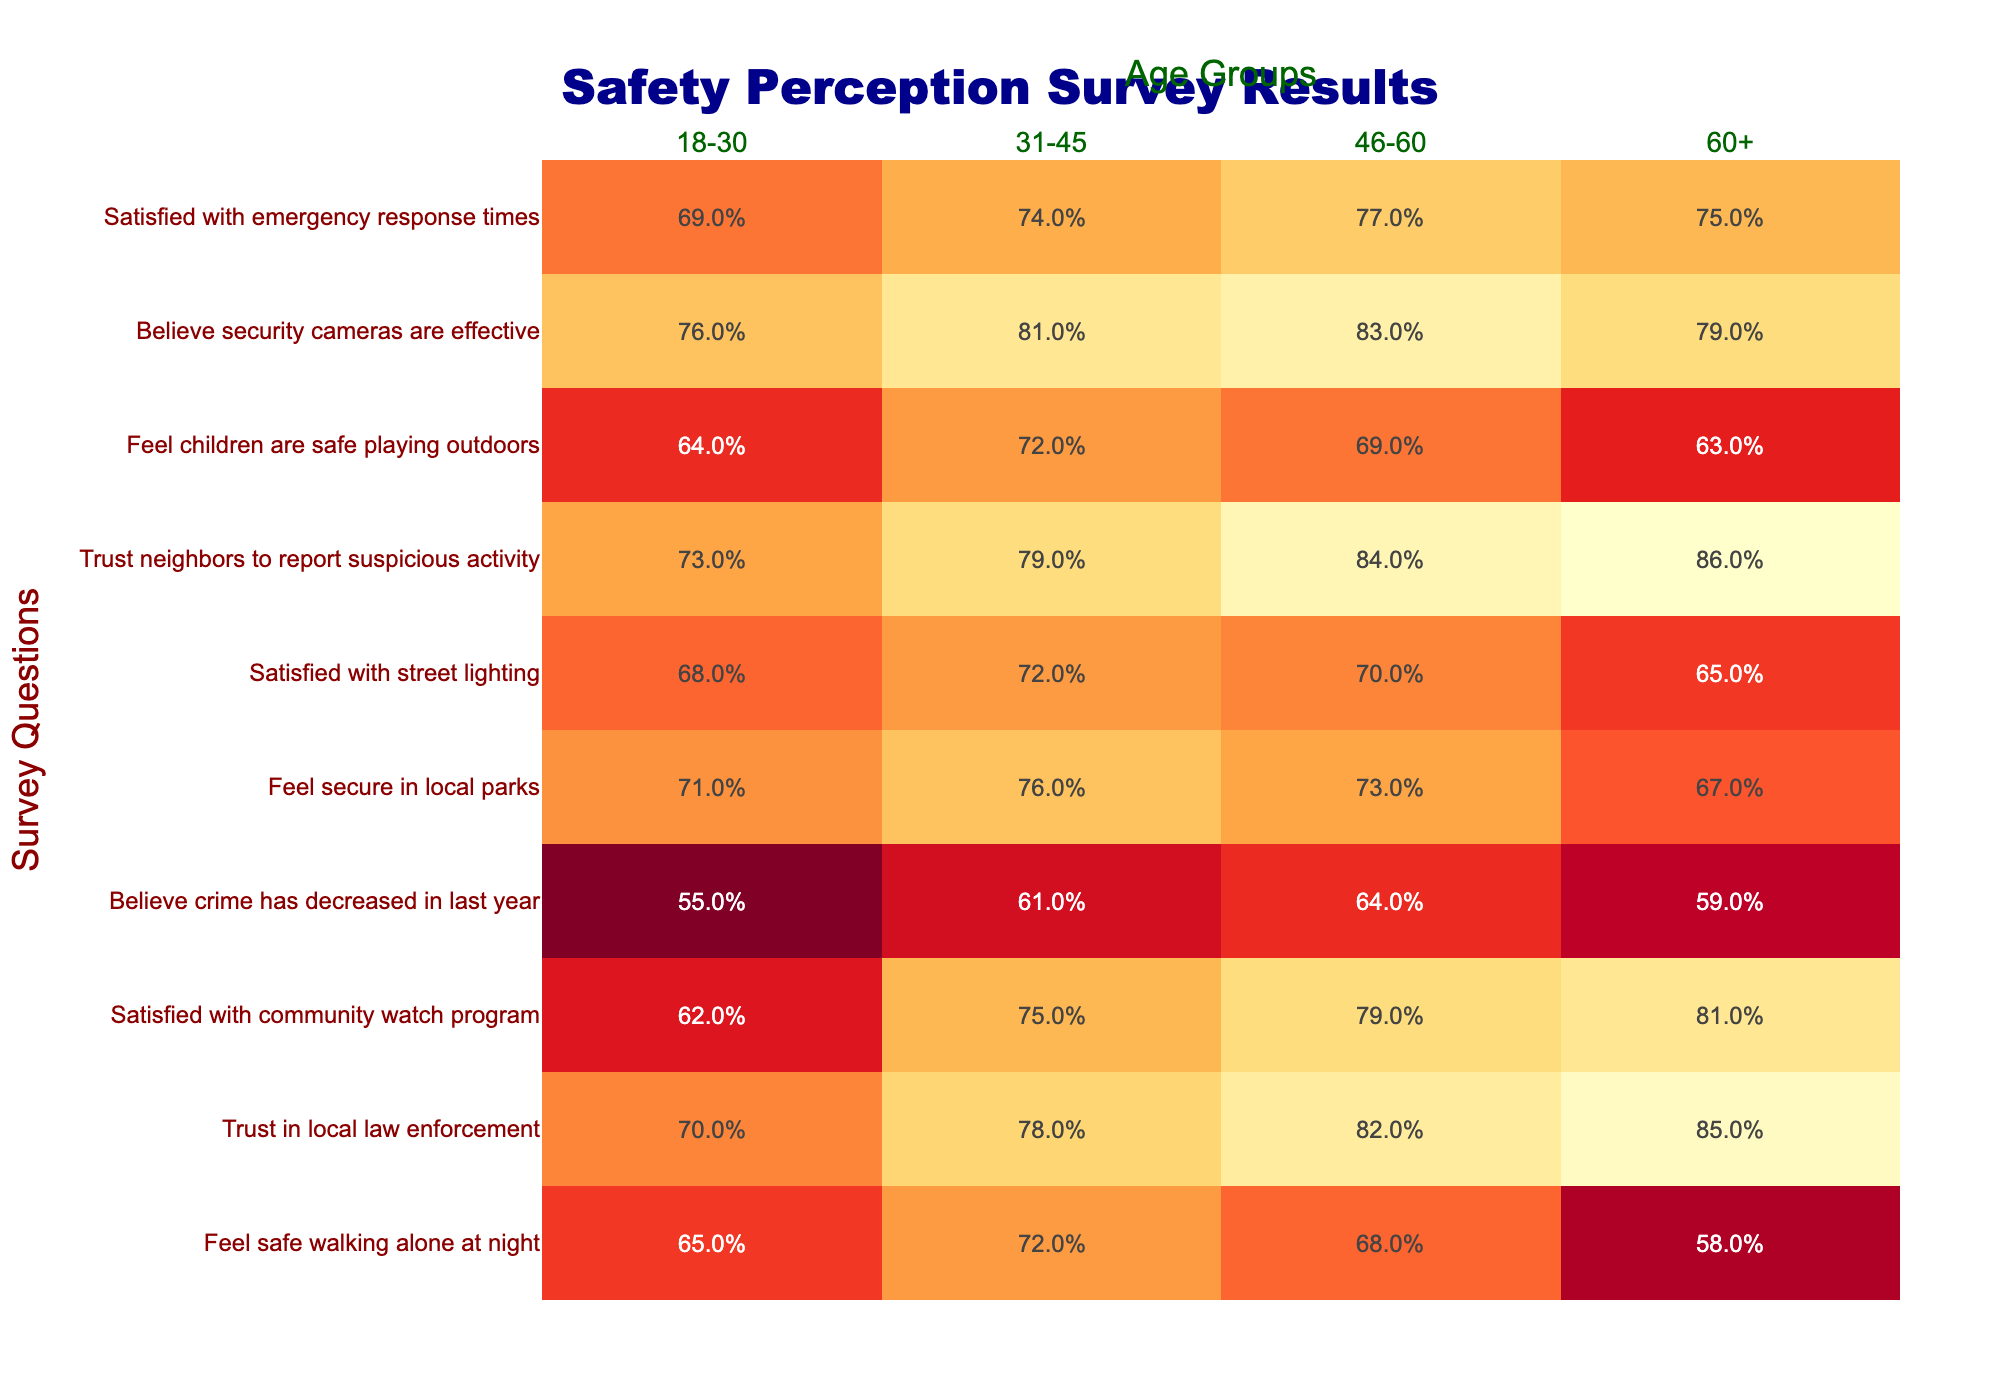What percentage of individuals aged 31-45 feel safe walking alone at night? According to the table, 72% of individuals in the 31-45 age group feel safe walking alone at night.
Answer: 72% Which age group has the highest trust in local law enforcement? The data shows that the 60+ age group has the highest trust in local law enforcement at 85%.
Answer: 60+ age group What is the percentage of individuals aged 18-30 who are satisfied with the community watch program? The table indicates that 62% of individuals aged 18-30 are satisfied with the community watch program.
Answer: 62% Calculate the average percentage of individuals across all age groups who feel secure in local parks. Adding the percentages from all age groups: (71% + 76% + 73% + 67%) = 287%. Dividing by 4 gives an average of 71.75%.
Answer: 71.75% Is the percentage of people who believe crime has decreased higher for the 31-45 age group than for the 60+ age group? The table shows that 31-45 age group has 61% and the 60+ age group has 59%. Since 61% is greater than 59%, the statement is true.
Answer: Yes What is the difference in satisfaction with street lighting between the 18-30 and 60+ age groups? The satisfaction for the 18-30 age group is 68% and for the 60+ age group, it is 65%. The difference is 68% - 65% = 3%.
Answer: 3% How many age groups reported a satisfaction rate of over 75% for the community watch program? From the table, the age groups 31-45 (75%), 46-60 (79%), and 60+ (81%) reported a satisfaction rate over 75%. This totals to 3 age groups.
Answer: 3 age groups Which age group has the lowest percentage believing that security cameras are effective? The table lists the effectiveness of security cameras at 76% for the 18-30 age group and 79% for the 60+ age group. So, the 18-30 age group has the lowest percentage.
Answer: 18-30 age group What is the relationship between the feeling of safety while walking alone at night and trust in local law enforcement for those aged 46-60? For the 46-60 age group, 68% feel safe walking alone at night and 82% trust local law enforcement. Both values indicate a positive perception of safety.
Answer: Positive relationship Are neighbors in the 60+ age group perceived as more trustworthy in reporting suspicious activity compared to the 18-30 age group? The table indicates 86% for the 60+ age group and 73% for the 18-30 age group, meaning the 60+ age group is perceived as more trustworthy.
Answer: Yes 